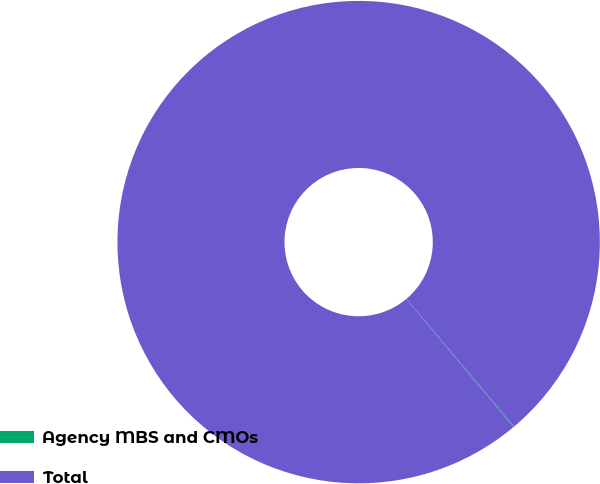Convert chart to OTSL. <chart><loc_0><loc_0><loc_500><loc_500><pie_chart><fcel>Agency MBS and CMOs<fcel>Total<nl><fcel>0.05%<fcel>99.95%<nl></chart> 